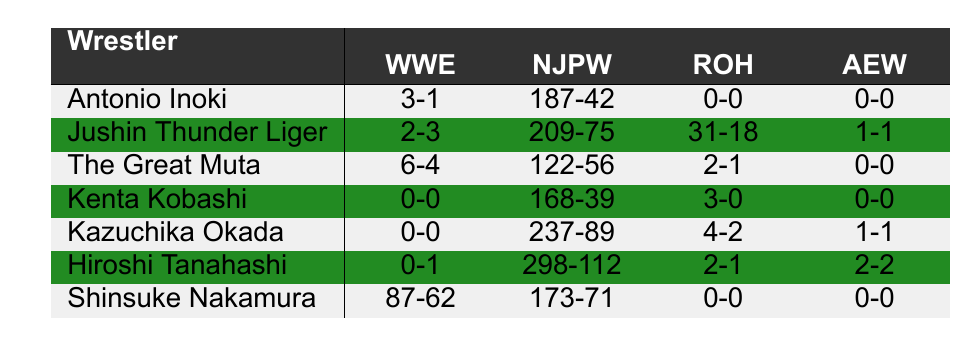What is the total number of wins for Shinsuke Nakamura in WWE? According to the table, Shinsuke Nakamura has 87 wins in WWE.
Answer: 87 How many losses does Kenta Kobashi have in NJPW? The table shows that Kenta Kobashi has 39 losses in NJPW.
Answer: 39 Who has the most wins in all promotions combined? By summing the wins across all promotions for each wrestler, Jushin Thunder Liger has the most at 251 wins (2 + 209 + 31 + 1).
Answer: Jushin Thunder Liger What is the win-loss record for Antonio Inoki in WWE and NJPW combined? Antonio Inoki has 3 wins and 1 loss in WWE, and 187 wins and 42 losses in NJPW. Adding these together gives a total of 190 wins and 43 losses.
Answer: 190-43 Is Hiroshi Tanahashi undefeated in ROH? The table indicates that Hiroshi Tanahashi has 2 wins and 1 loss in ROH, which means he is not undefeated.
Answer: No What is the average number of wins for the wrestlers listed in AEW? The total wins in AEW are 5 (2 for Hiroshi Tanahashi + 1 for Kazuchika Okada + 0 for the others), and there are 6 wrestlers, so average = 5/6 ≈ 0.83.
Answer: 0.83 Which wrestler has the highest loss count in NJPW? By examining the NJPW losses column, Kazuchika Okada has the highest loss count at 89.
Answer: Kazuchika Okada What is the win-to-loss ratio for The Great Muta in NJPW? The Great Muta has 122 wins and 56 losses in NJPW. The win-to-loss ratio is calculated as 122/56, which simplifies to approximately 2.18.
Answer: 2.18 How many total wins does Jushin Thunder Liger have in international promotions? Jushin Thunder Liger has 2 wins in WWE, 209 in NJPW, 31 in ROH, and 1 in AEW, totaling 243 wins.
Answer: 243 Which wrestler has a perfect record in ROH? By looking at the table, Kenta Kobashi has a record of 3 wins and 0 losses, which is a perfect record in ROH.
Answer: Kenta Kobashi 